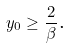<formula> <loc_0><loc_0><loc_500><loc_500>y _ { 0 } \geq \frac { 2 } { \beta } \text {. }</formula> 